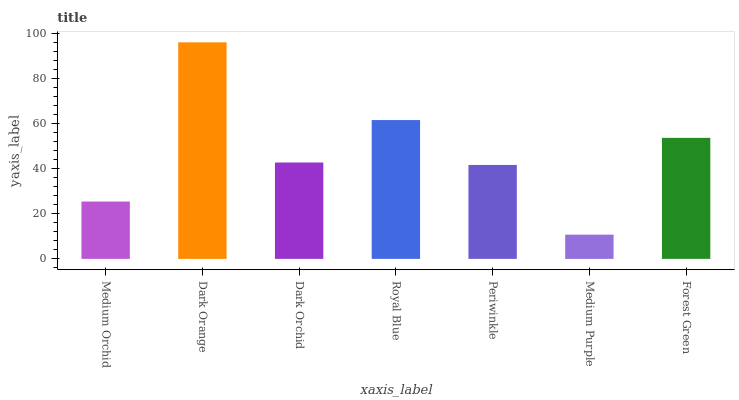Is Medium Purple the minimum?
Answer yes or no. Yes. Is Dark Orange the maximum?
Answer yes or no. Yes. Is Dark Orchid the minimum?
Answer yes or no. No. Is Dark Orchid the maximum?
Answer yes or no. No. Is Dark Orange greater than Dark Orchid?
Answer yes or no. Yes. Is Dark Orchid less than Dark Orange?
Answer yes or no. Yes. Is Dark Orchid greater than Dark Orange?
Answer yes or no. No. Is Dark Orange less than Dark Orchid?
Answer yes or no. No. Is Dark Orchid the high median?
Answer yes or no. Yes. Is Dark Orchid the low median?
Answer yes or no. Yes. Is Royal Blue the high median?
Answer yes or no. No. Is Forest Green the low median?
Answer yes or no. No. 